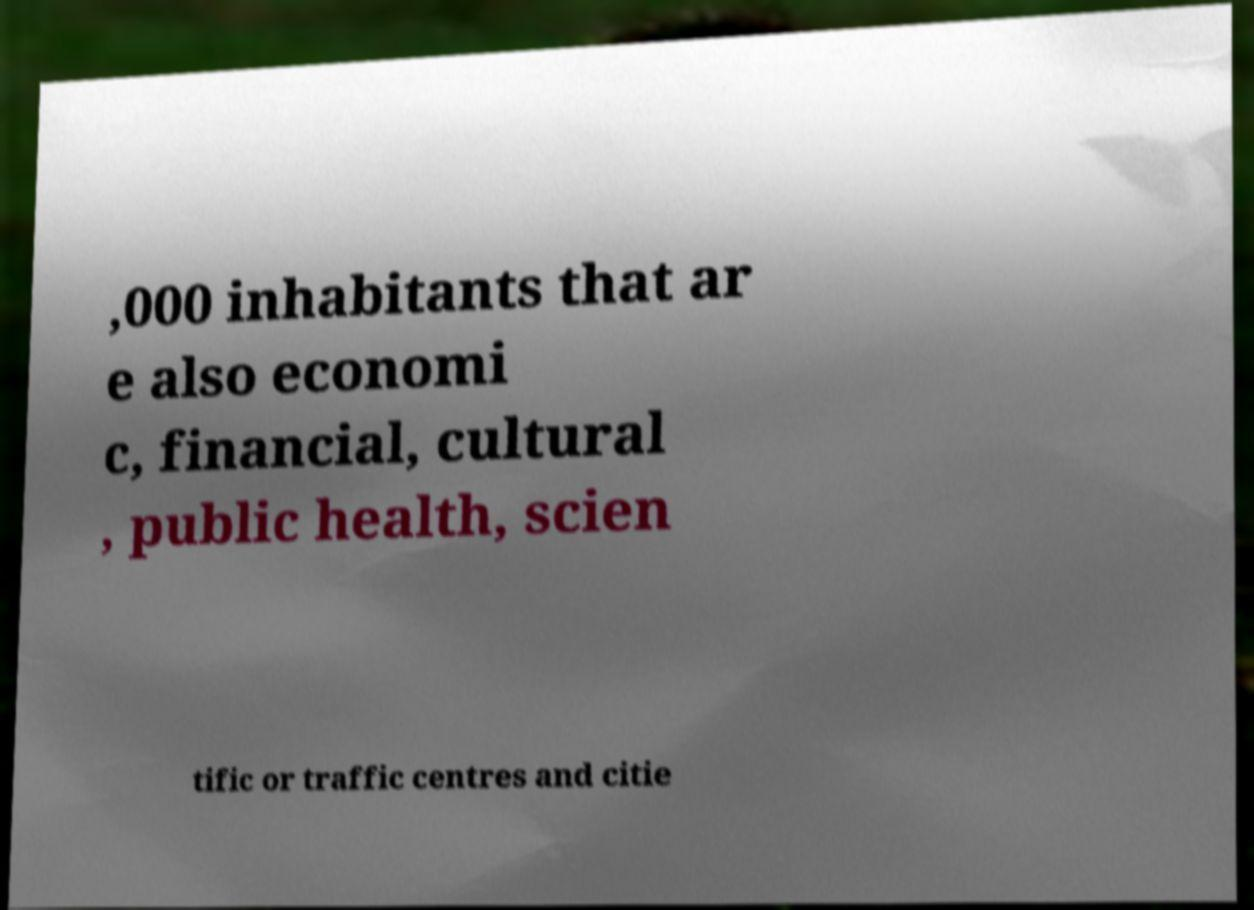I need the written content from this picture converted into text. Can you do that? ,000 inhabitants that ar e also economi c, financial, cultural , public health, scien tific or traffic centres and citie 